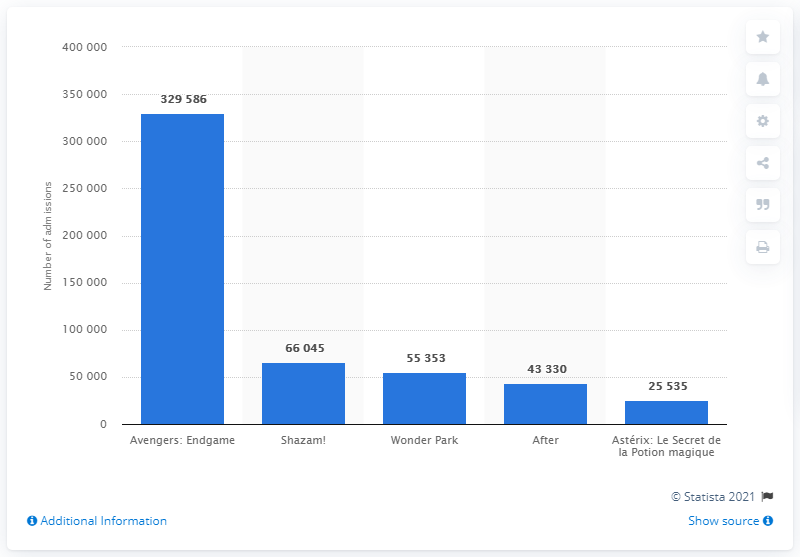Draw attention to some important aspects in this diagram. The fourth Avengers movie was viewed by 329,586 people in Norway. It is estimated that 'Shazam!' was viewed by 66,045 people. 